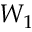Convert formula to latex. <formula><loc_0><loc_0><loc_500><loc_500>W _ { 1 }</formula> 